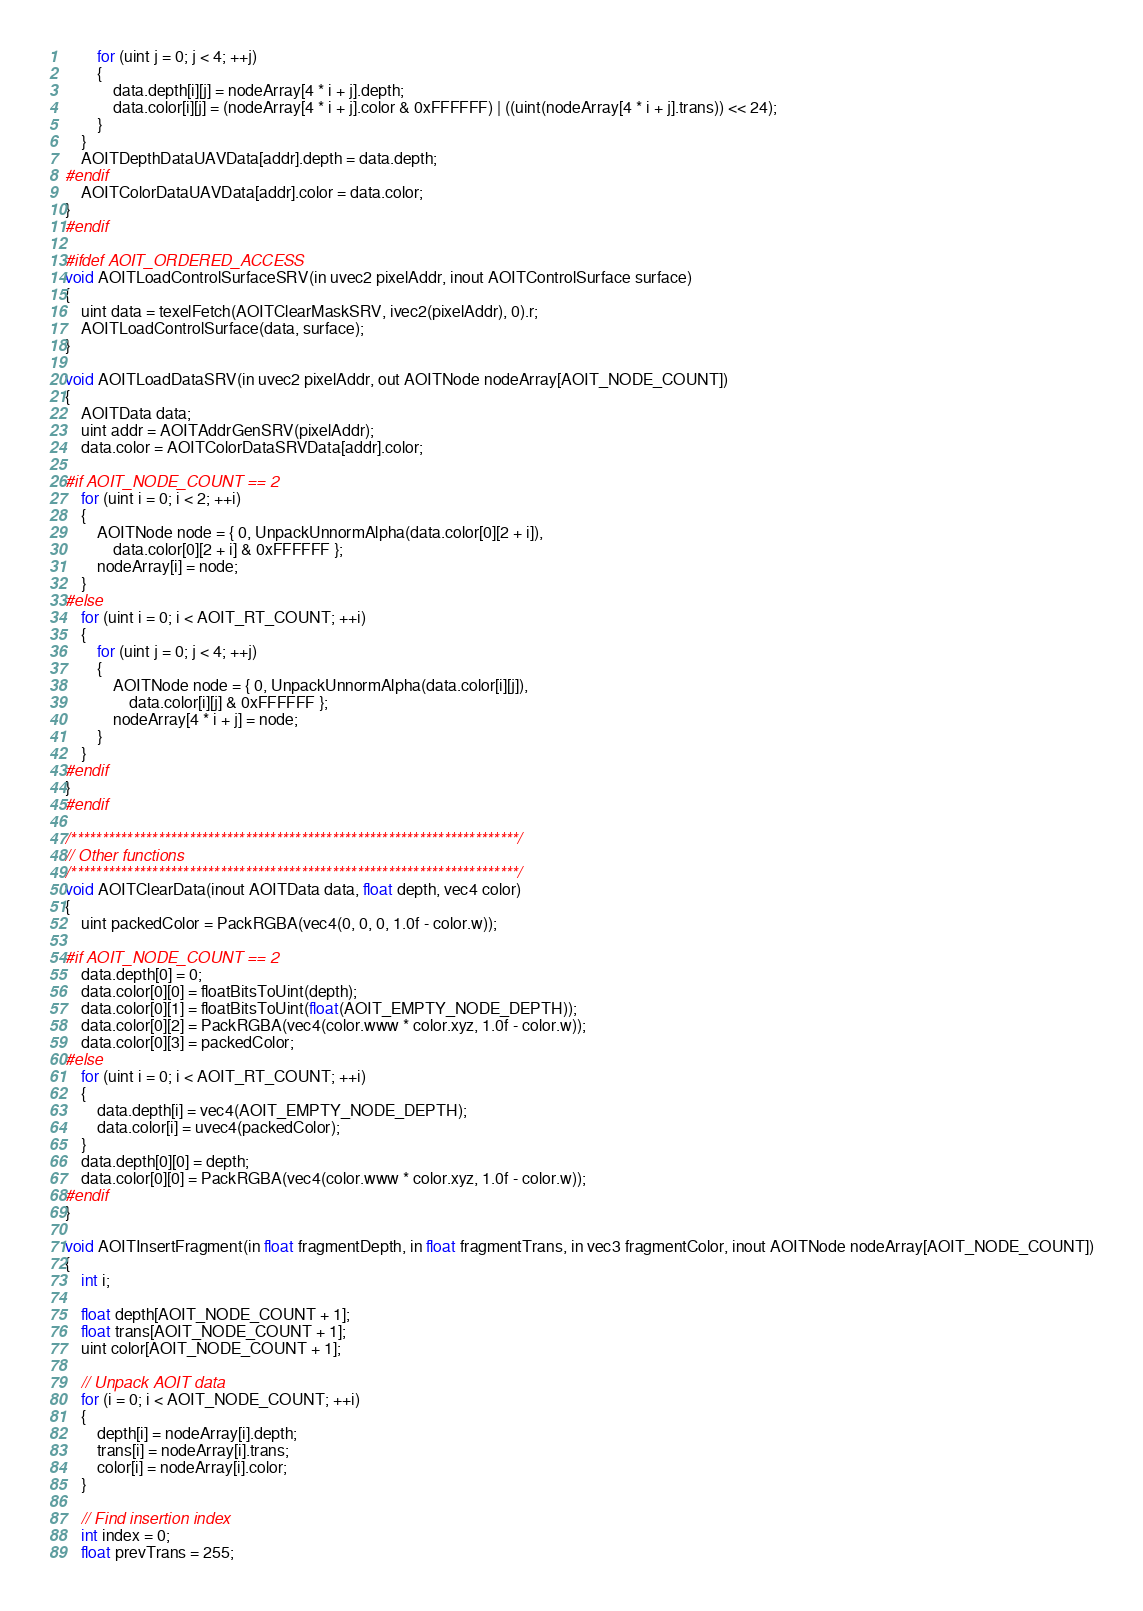<code> <loc_0><loc_0><loc_500><loc_500><_C_>		for (uint j = 0; j < 4; ++j)
		{
			data.depth[i][j] = nodeArray[4 * i + j].depth;
			data.color[i][j] = (nodeArray[4 * i + j].color & 0xFFFFFF) | ((uint(nodeArray[4 * i + j].trans)) << 24);
		}
	}
	AOITDepthDataUAVData[addr].depth = data.depth;
#endif
	AOITColorDataUAVData[addr].color = data.color;
}
#endif

#ifdef AOIT_ORDERED_ACCESS
void AOITLoadControlSurfaceSRV(in uvec2 pixelAddr, inout AOITControlSurface surface)
{
	uint data = texelFetch(AOITClearMaskSRV, ivec2(pixelAddr), 0).r;
	AOITLoadControlSurface(data, surface);
}

void AOITLoadDataSRV(in uvec2 pixelAddr, out AOITNode nodeArray[AOIT_NODE_COUNT])
{
	AOITData data;
	uint addr = AOITAddrGenSRV(pixelAddr);
	data.color = AOITColorDataSRVData[addr].color;

#if AOIT_NODE_COUNT == 2
	for (uint i = 0; i < 2; ++i)
	{
		AOITNode node = { 0, UnpackUnnormAlpha(data.color[0][2 + i]),
			data.color[0][2 + i] & 0xFFFFFF };
		nodeArray[i] = node;
	}
#else
	for (uint i = 0; i < AOIT_RT_COUNT; ++i)
	{
		for (uint j = 0; j < 4; ++j)
		{
			AOITNode node = { 0, UnpackUnnormAlpha(data.color[i][j]),
				data.color[i][j] & 0xFFFFFF };
			nodeArray[4 * i + j] = node;
		}
	}
#endif
}
#endif

/************************************************************************/
// Other functions
/************************************************************************/
void AOITClearData(inout AOITData data, float depth, vec4 color)
{
	uint packedColor = PackRGBA(vec4(0, 0, 0, 1.0f - color.w));

#if AOIT_NODE_COUNT == 2
	data.depth[0] = 0;
	data.color[0][0] = floatBitsToUint(depth);
	data.color[0][1] = floatBitsToUint(float(AOIT_EMPTY_NODE_DEPTH));
	data.color[0][2] = PackRGBA(vec4(color.www * color.xyz, 1.0f - color.w));
	data.color[0][3] = packedColor;
#else
	for (uint i = 0; i < AOIT_RT_COUNT; ++i)
	{
		data.depth[i] = vec4(AOIT_EMPTY_NODE_DEPTH);
		data.color[i] = uvec4(packedColor);
	}
	data.depth[0][0] = depth;
	data.color[0][0] = PackRGBA(vec4(color.www * color.xyz, 1.0f - color.w));
#endif
}

void AOITInsertFragment(in float fragmentDepth, in float fragmentTrans, in vec3 fragmentColor, inout AOITNode nodeArray[AOIT_NODE_COUNT])
{
	int i;

	float depth[AOIT_NODE_COUNT + 1];
	float trans[AOIT_NODE_COUNT + 1];
	uint color[AOIT_NODE_COUNT + 1];

	// Unpack AOIT data
	for (i = 0; i < AOIT_NODE_COUNT; ++i)
	{
		depth[i] = nodeArray[i].depth;
		trans[i] = nodeArray[i].trans;
		color[i] = nodeArray[i].color;
	}

	// Find insertion index
	int index = 0;
	float prevTrans = 255;</code> 